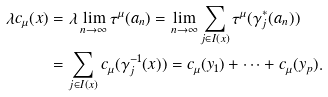Convert formula to latex. <formula><loc_0><loc_0><loc_500><loc_500>\lambda c _ { \mu } ( x ) & = \lambda \lim _ { n \to \infty } \tau ^ { \mu } ( a _ { n } ) = \lim _ { n \to \infty } \sum _ { j \in I ( x ) } \tau ^ { \mu } ( \gamma _ { j } ^ { * } ( a _ { n } ) ) \\ & = \sum _ { j \in I ( x ) } c _ { \mu } ( \gamma _ { j } ^ { - 1 } ( x ) ) = c _ { \mu } ( y _ { 1 } ) + \cdots + c _ { \mu } ( y _ { p } ) .</formula> 